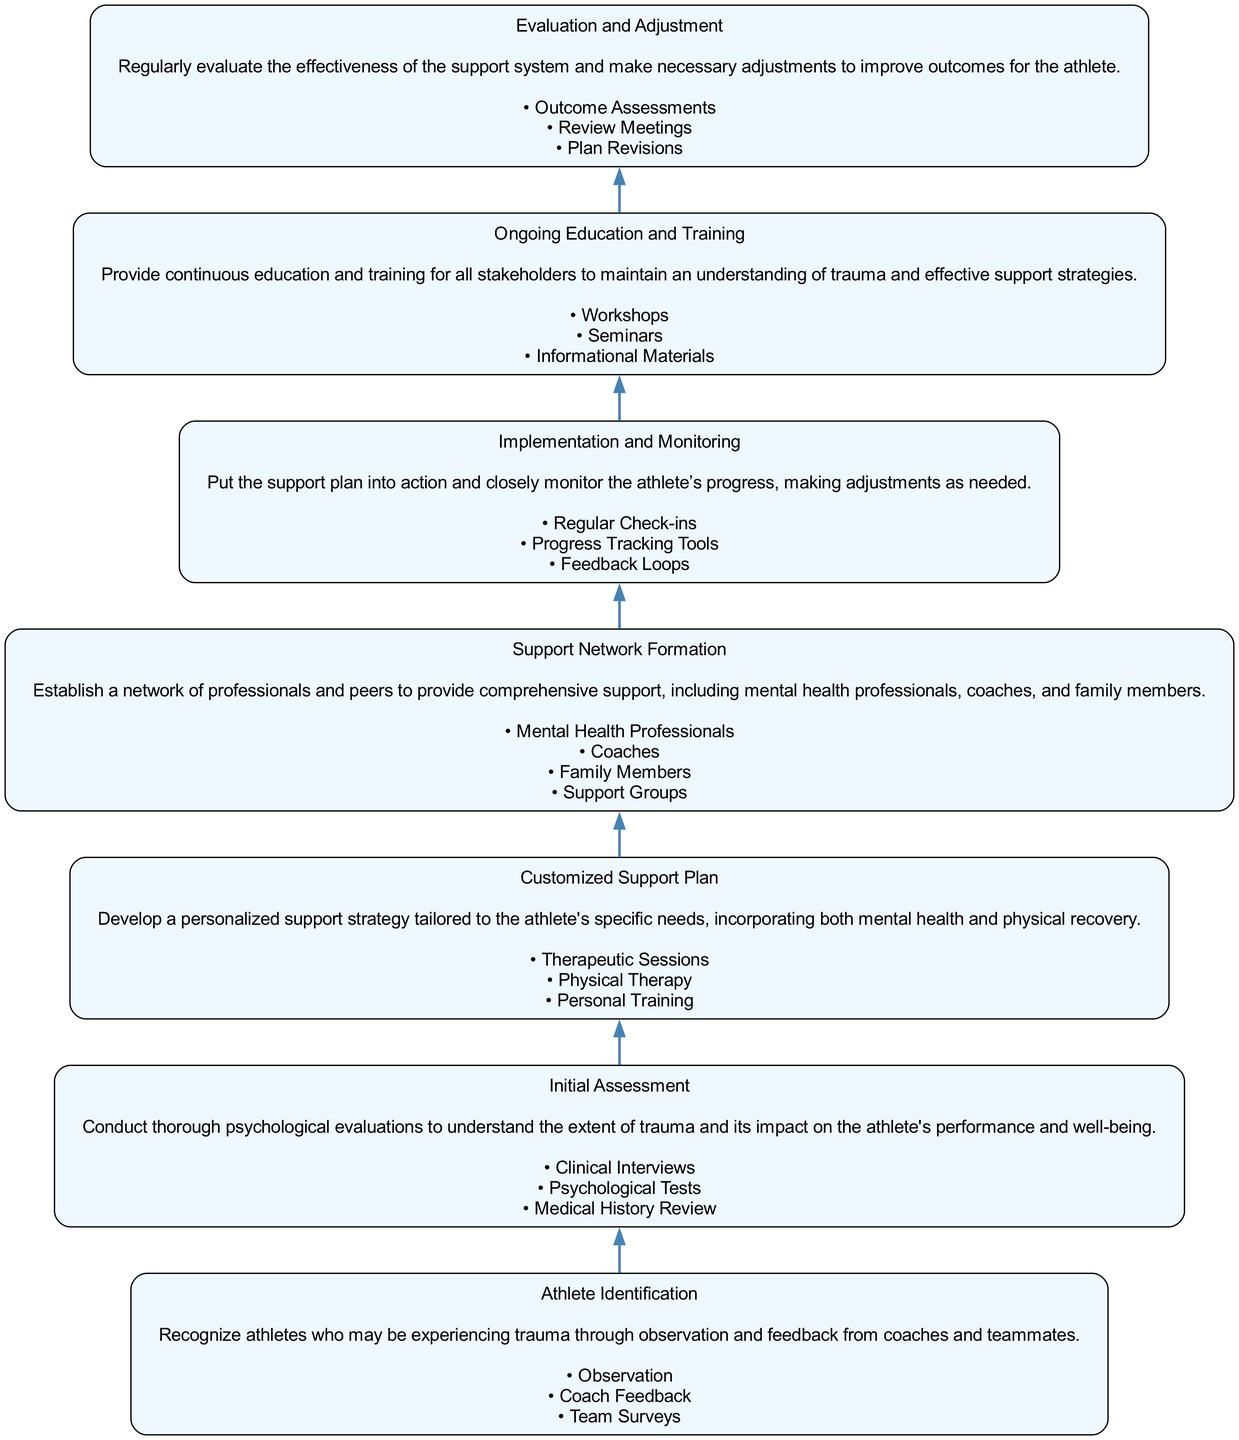What is the first step in the flow chart? The first step in the flow chart is "Athlete Identification." This is determined by looking at the ordering of the nodes from bottom to top. The first node at the bottom is always the initial step.
Answer: Athlete Identification How many nodes are present in the flow chart? To find this, count the distinct steps listed in the diagram. There are seven distinct steps outlined, from "Athlete Identification" up to "Evaluation and Adjustment."
Answer: Seven Which node follows "Support Network Formation"? Check the order of the nodes in the flow chart. The node that directly follows "Support Network Formation" is "Implementation and Monitoring." This is inferred from the directional connections shown between the nodes.
Answer: Implementation and Monitoring What types of entities are involved in the "Customized Support Plan"? Look at the specific section of the "Customized Support Plan" node to see what real-world entities are listed. The entities involved include "Therapeutic Sessions," "Physical Therapy," and "Personal Training."
Answer: Therapeutic Sessions, Physical Therapy, Personal Training Which node mainly focuses on providing continuous education for stakeholders? Identify the node that discusses education. The "Ongoing Education and Training" node is designed specifically to provide continuous training and updates for everyone involved in the support system.
Answer: Ongoing Education and Training What is the purpose of the "Evaluation and Adjustment" node? Analyze the description of the "Evaluation and Adjustment" node to determine its function. Its purpose is to regularly evaluate the effectiveness of the support system, allowing for necessary adjustments to improve outcomes.
Answer: Regularly evaluate the effectiveness of the support system What comes after "Implementation and Monitoring"? Following the connections in the flow chart, the node that comes immediately after "Implementation and Monitoring" is "Ongoing Education and Training." This relationship shows how actions lead to continuous improvement.
Answer: Ongoing Education and Training How are professionals involved in the "Support Network Formation"? Look at the list of real-world entities under "Support Network Formation." The professionals involved include "Mental Health Professionals," "Coaches," "Family Members," and various support groups, which all contribute to creating a comprehensive support system.
Answer: Mental Health Professionals, Coaches, Family Members, Support Groups 